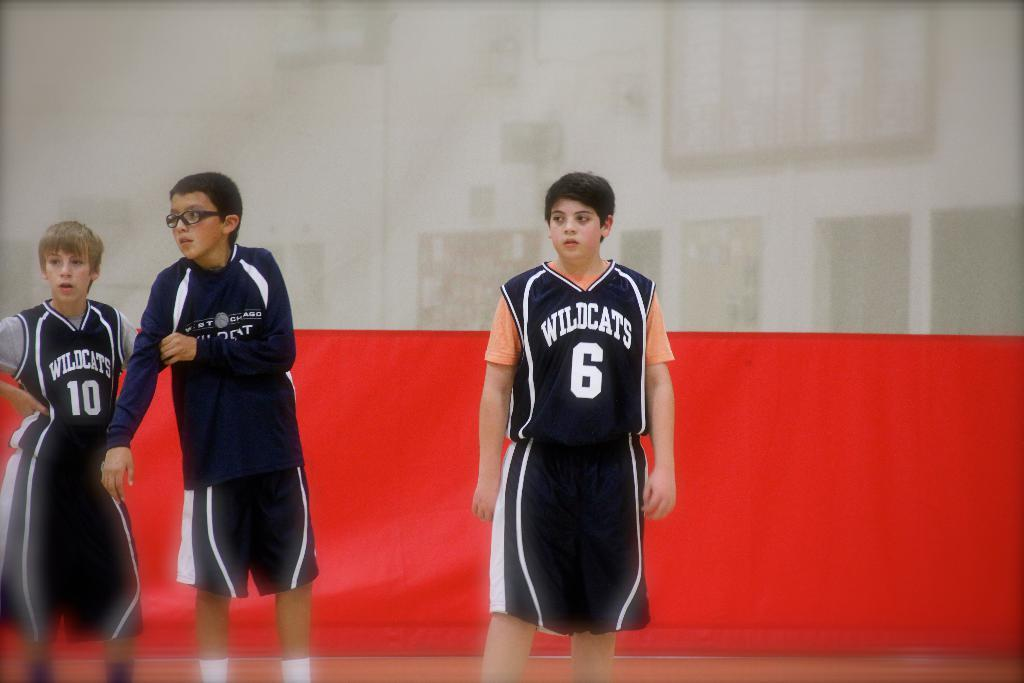<image>
Create a compact narrative representing the image presented. wildcats basketball players watching the basketball game number 6 